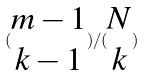<formula> <loc_0><loc_0><loc_500><loc_500>( \begin{matrix} m - 1 \\ k - 1 \end{matrix} ) / ( \begin{matrix} N \\ k \end{matrix} )</formula> 